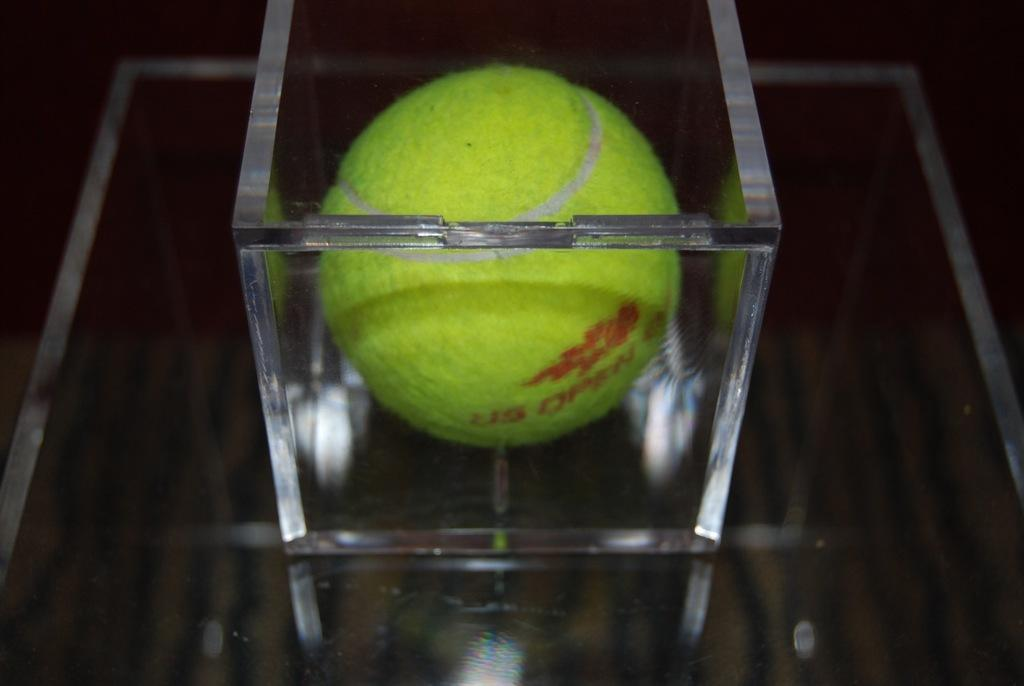What is the main object in the image? There is a glass box in the image. What is inside the glass box? There is a ball inside the glass box. What colors are visible on the ball? The ball is red and yellow in color. How would you describe the overall appearance of the image? The background of the image is dark. Can you tell me how many people are walking on the sidewalk in the image? There is no sidewalk present in the image, so it is not possible to determine the number of people walking on it. 